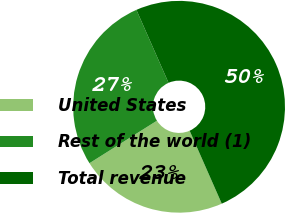Convert chart. <chart><loc_0><loc_0><loc_500><loc_500><pie_chart><fcel>United States<fcel>Rest of the world (1)<fcel>Total revenue<nl><fcel>22.66%<fcel>27.34%<fcel>50.0%<nl></chart> 